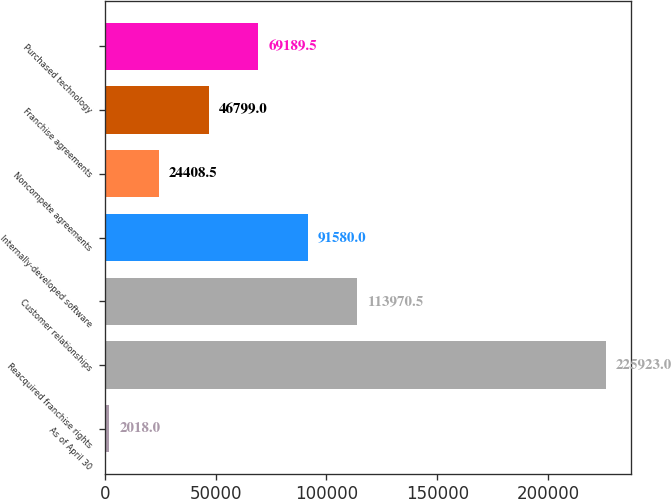Convert chart. <chart><loc_0><loc_0><loc_500><loc_500><bar_chart><fcel>As of April 30<fcel>Reacquired franchise rights<fcel>Customer relationships<fcel>Internally-developed software<fcel>Noncompete agreements<fcel>Franchise agreements<fcel>Purchased technology<nl><fcel>2018<fcel>225923<fcel>113970<fcel>91580<fcel>24408.5<fcel>46799<fcel>69189.5<nl></chart> 